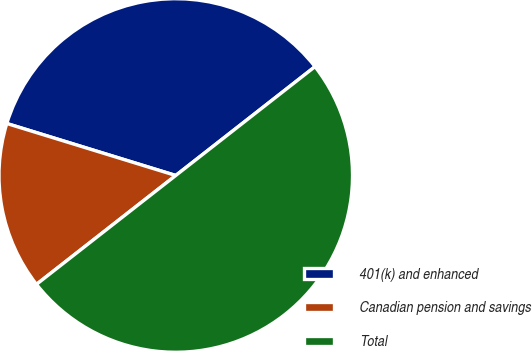Convert chart to OTSL. <chart><loc_0><loc_0><loc_500><loc_500><pie_chart><fcel>401(k) and enhanced<fcel>Canadian pension and savings<fcel>Total<nl><fcel>34.69%<fcel>15.31%<fcel>50.0%<nl></chart> 